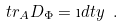<formula> <loc_0><loc_0><loc_500><loc_500>\ t r _ { A } D _ { \Phi } = \i d t y \ .</formula> 